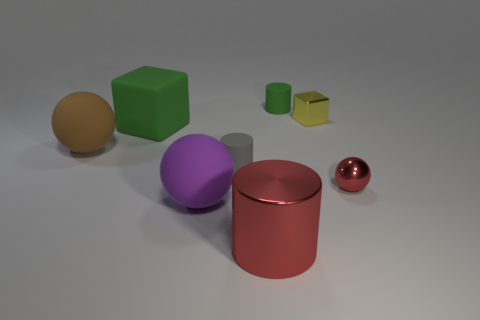What is the color of the matte block?
Keep it short and to the point. Green. Do the large cylinder and the sphere that is behind the tiny red metal sphere have the same material?
Make the answer very short. No. The small yellow object that is the same material as the red cylinder is what shape?
Make the answer very short. Cube. What is the color of the sphere that is the same size as the yellow object?
Make the answer very short. Red. Do the matte cylinder that is in front of the green rubber cube and the small green rubber cylinder have the same size?
Offer a terse response. Yes. Do the shiny cylinder and the big cube have the same color?
Your response must be concise. No. How many large gray shiny spheres are there?
Provide a succinct answer. 0. How many blocks are either tiny red things or purple things?
Offer a terse response. 0. How many red cylinders are behind the red metal thing that is left of the small green cylinder?
Make the answer very short. 0. Are the small cube and the large cylinder made of the same material?
Your answer should be compact. Yes. 